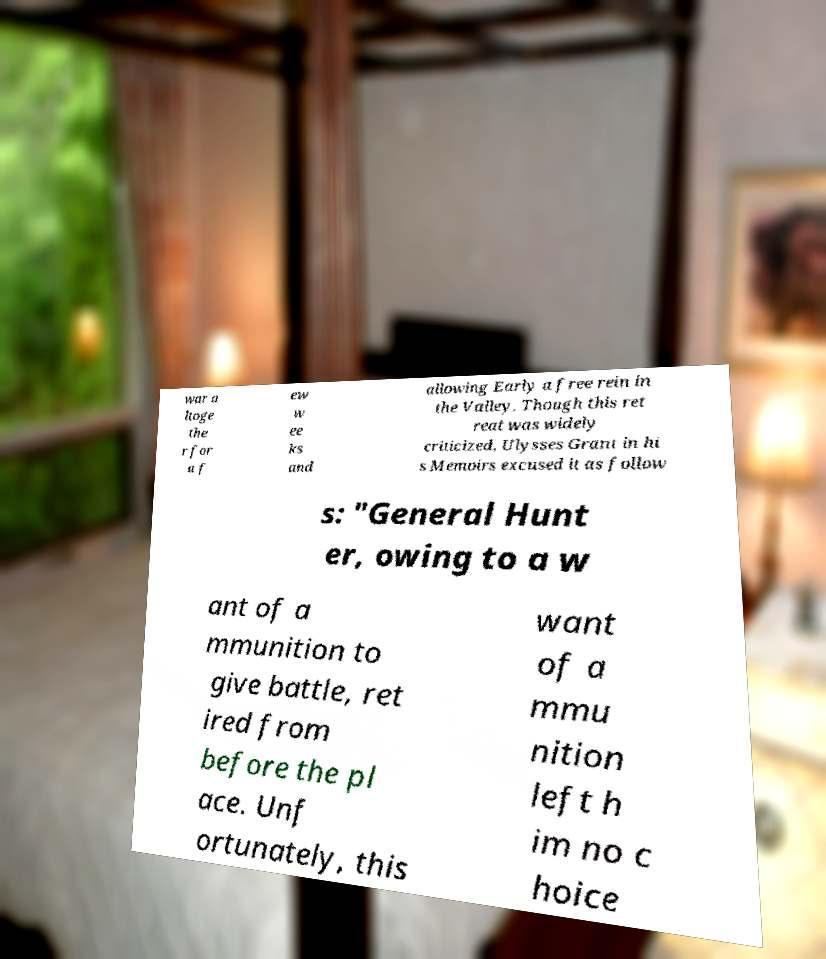There's text embedded in this image that I need extracted. Can you transcribe it verbatim? war a ltoge the r for a f ew w ee ks and allowing Early a free rein in the Valley. Though this ret reat was widely criticized, Ulysses Grant in hi s Memoirs excused it as follow s: "General Hunt er, owing to a w ant of a mmunition to give battle, ret ired from before the pl ace. Unf ortunately, this want of a mmu nition left h im no c hoice 